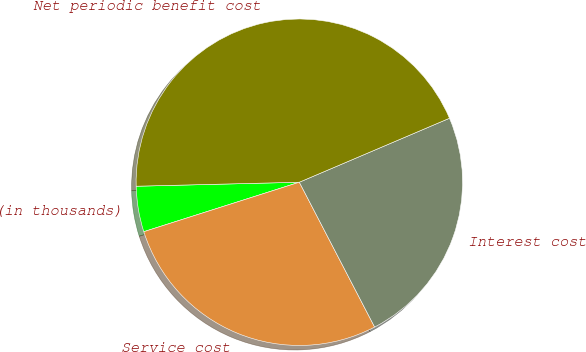Convert chart to OTSL. <chart><loc_0><loc_0><loc_500><loc_500><pie_chart><fcel>(in thousands)<fcel>Service cost<fcel>Interest cost<fcel>Net periodic benefit cost<nl><fcel>4.51%<fcel>27.73%<fcel>23.78%<fcel>43.98%<nl></chart> 